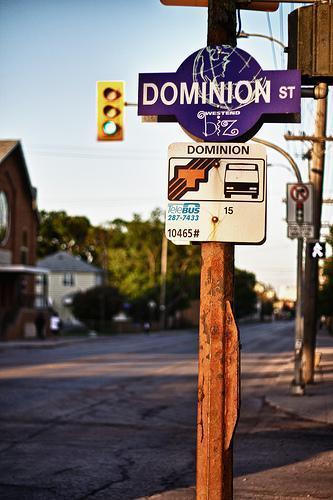How many signs can be seen?
Give a very brief answer. 4. 